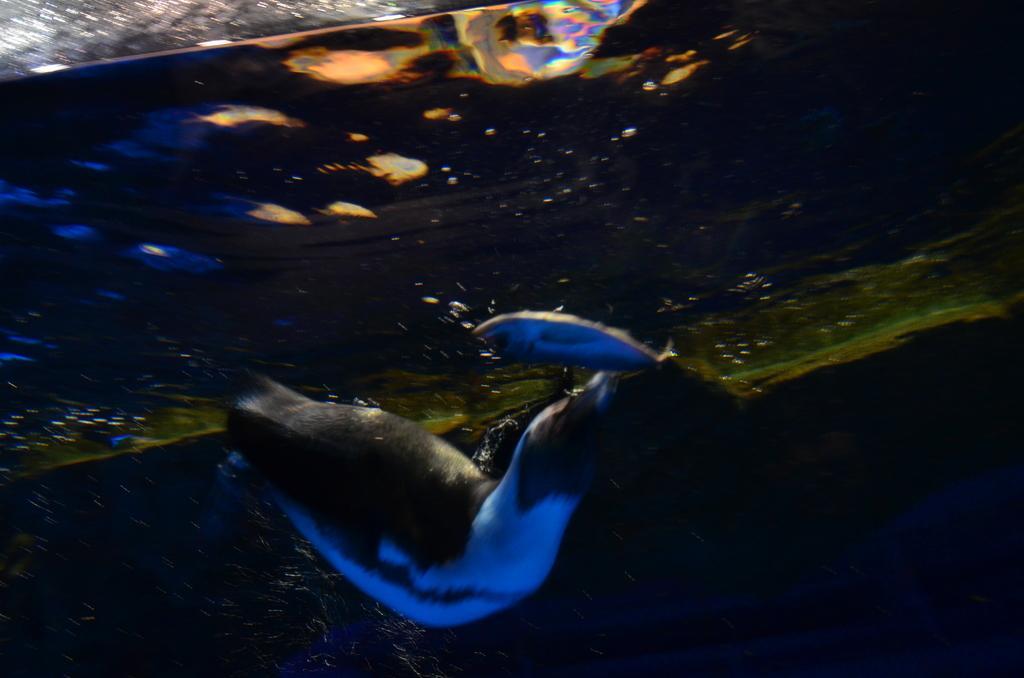What type of animals can be seen in the image? There are fishes in the water. Can you describe the other animal in the image? There is an animal in white and black color in the image. What type of office equipment can be seen in the image? There is no office equipment present in the image; it features fishes in the water and an animal in white and black color. What type of alarm is going off in the image? There is no alarm present in the image. 